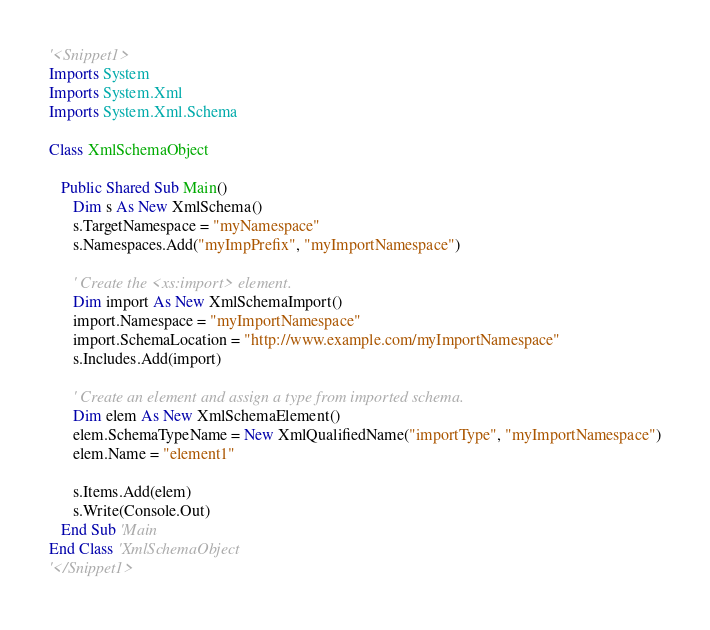Convert code to text. <code><loc_0><loc_0><loc_500><loc_500><_VisualBasic_>'<Snippet1>
Imports System
Imports System.Xml
Imports System.Xml.Schema

Class XmlSchemaObject
   
   Public Shared Sub Main()
      Dim s As New XmlSchema()
      s.TargetNamespace = "myNamespace"
      s.Namespaces.Add("myImpPrefix", "myImportNamespace")
      
      ' Create the <xs:import> element.
      Dim import As New XmlSchemaImport()
      import.Namespace = "myImportNamespace"
      import.SchemaLocation = "http://www.example.com/myImportNamespace"
      s.Includes.Add(import)
      
      ' Create an element and assign a type from imported schema.
      Dim elem As New XmlSchemaElement()
      elem.SchemaTypeName = New XmlQualifiedName("importType", "myImportNamespace")
      elem.Name = "element1"
      
      s.Items.Add(elem)
      s.Write(Console.Out)
   End Sub 'Main 
End Class 'XmlSchemaObject
'</Snippet1>
</code> 